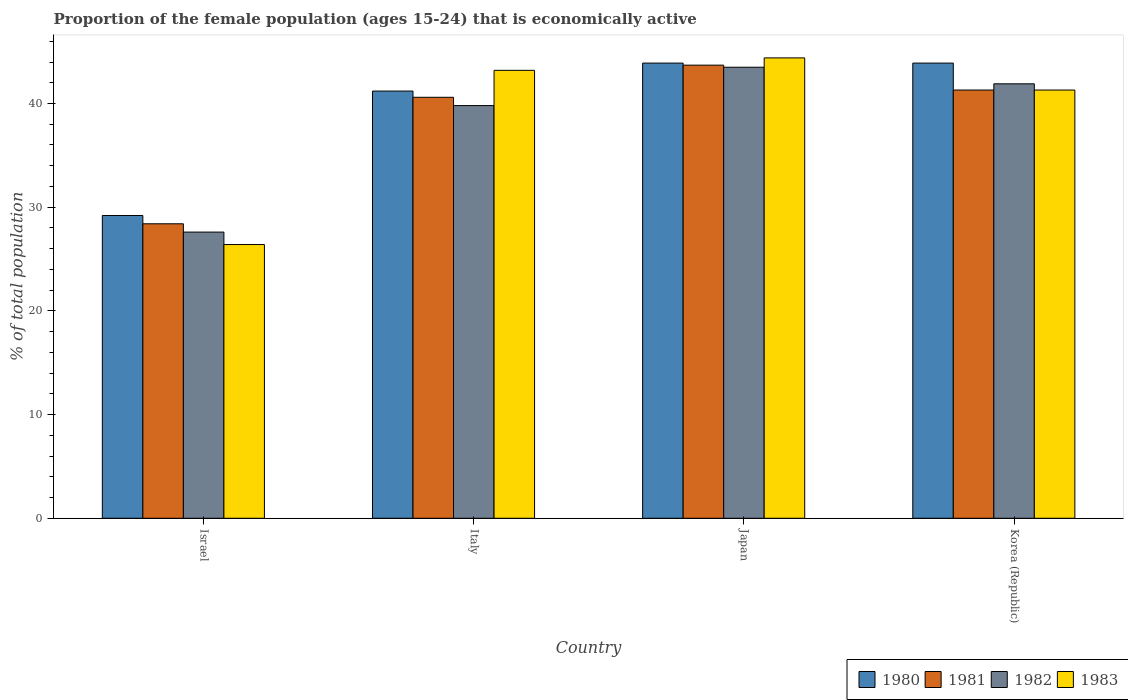How many groups of bars are there?
Offer a terse response. 4. Are the number of bars per tick equal to the number of legend labels?
Offer a very short reply. Yes. How many bars are there on the 4th tick from the left?
Offer a very short reply. 4. What is the label of the 2nd group of bars from the left?
Provide a short and direct response. Italy. What is the proportion of the female population that is economically active in 1981 in Italy?
Give a very brief answer. 40.6. Across all countries, what is the maximum proportion of the female population that is economically active in 1981?
Provide a short and direct response. 43.7. Across all countries, what is the minimum proportion of the female population that is economically active in 1982?
Ensure brevity in your answer.  27.6. In which country was the proportion of the female population that is economically active in 1980 maximum?
Offer a terse response. Japan. What is the total proportion of the female population that is economically active in 1982 in the graph?
Provide a succinct answer. 152.8. What is the difference between the proportion of the female population that is economically active in 1982 in Israel and that in Italy?
Offer a very short reply. -12.2. What is the difference between the proportion of the female population that is economically active in 1980 in Japan and the proportion of the female population that is economically active in 1983 in Italy?
Your response must be concise. 0.7. What is the average proportion of the female population that is economically active in 1982 per country?
Your answer should be very brief. 38.2. What is the difference between the proportion of the female population that is economically active of/in 1982 and proportion of the female population that is economically active of/in 1983 in Korea (Republic)?
Give a very brief answer. 0.6. In how many countries, is the proportion of the female population that is economically active in 1980 greater than 12 %?
Ensure brevity in your answer.  4. What is the ratio of the proportion of the female population that is economically active in 1980 in Italy to that in Korea (Republic)?
Ensure brevity in your answer.  0.94. Is the proportion of the female population that is economically active in 1982 in Italy less than that in Korea (Republic)?
Offer a very short reply. Yes. What is the difference between the highest and the second highest proportion of the female population that is economically active in 1981?
Make the answer very short. -0.7. What is the difference between the highest and the lowest proportion of the female population that is economically active in 1982?
Keep it short and to the point. 15.9. Is it the case that in every country, the sum of the proportion of the female population that is economically active in 1982 and proportion of the female population that is economically active in 1980 is greater than the sum of proportion of the female population that is economically active in 1981 and proportion of the female population that is economically active in 1983?
Offer a terse response. No. What does the 2nd bar from the left in Italy represents?
Ensure brevity in your answer.  1981. What does the 4th bar from the right in Italy represents?
Offer a very short reply. 1980. What is the difference between two consecutive major ticks on the Y-axis?
Your answer should be very brief. 10. Are the values on the major ticks of Y-axis written in scientific E-notation?
Provide a succinct answer. No. Does the graph contain any zero values?
Offer a very short reply. No. Does the graph contain grids?
Give a very brief answer. No. Where does the legend appear in the graph?
Ensure brevity in your answer.  Bottom right. How are the legend labels stacked?
Offer a very short reply. Horizontal. What is the title of the graph?
Ensure brevity in your answer.  Proportion of the female population (ages 15-24) that is economically active. Does "1988" appear as one of the legend labels in the graph?
Make the answer very short. No. What is the label or title of the X-axis?
Ensure brevity in your answer.  Country. What is the label or title of the Y-axis?
Provide a short and direct response. % of total population. What is the % of total population of 1980 in Israel?
Your response must be concise. 29.2. What is the % of total population of 1981 in Israel?
Make the answer very short. 28.4. What is the % of total population in 1982 in Israel?
Keep it short and to the point. 27.6. What is the % of total population in 1983 in Israel?
Offer a very short reply. 26.4. What is the % of total population of 1980 in Italy?
Keep it short and to the point. 41.2. What is the % of total population in 1981 in Italy?
Your answer should be compact. 40.6. What is the % of total population of 1982 in Italy?
Your response must be concise. 39.8. What is the % of total population in 1983 in Italy?
Make the answer very short. 43.2. What is the % of total population of 1980 in Japan?
Your answer should be compact. 43.9. What is the % of total population of 1981 in Japan?
Your response must be concise. 43.7. What is the % of total population in 1982 in Japan?
Give a very brief answer. 43.5. What is the % of total population of 1983 in Japan?
Make the answer very short. 44.4. What is the % of total population in 1980 in Korea (Republic)?
Make the answer very short. 43.9. What is the % of total population of 1981 in Korea (Republic)?
Your response must be concise. 41.3. What is the % of total population of 1982 in Korea (Republic)?
Your response must be concise. 41.9. What is the % of total population in 1983 in Korea (Republic)?
Make the answer very short. 41.3. Across all countries, what is the maximum % of total population in 1980?
Offer a terse response. 43.9. Across all countries, what is the maximum % of total population in 1981?
Your answer should be very brief. 43.7. Across all countries, what is the maximum % of total population in 1982?
Provide a short and direct response. 43.5. Across all countries, what is the maximum % of total population of 1983?
Provide a short and direct response. 44.4. Across all countries, what is the minimum % of total population of 1980?
Ensure brevity in your answer.  29.2. Across all countries, what is the minimum % of total population in 1981?
Keep it short and to the point. 28.4. Across all countries, what is the minimum % of total population of 1982?
Provide a short and direct response. 27.6. Across all countries, what is the minimum % of total population of 1983?
Provide a succinct answer. 26.4. What is the total % of total population in 1980 in the graph?
Provide a succinct answer. 158.2. What is the total % of total population of 1981 in the graph?
Offer a very short reply. 154. What is the total % of total population in 1982 in the graph?
Your answer should be very brief. 152.8. What is the total % of total population in 1983 in the graph?
Give a very brief answer. 155.3. What is the difference between the % of total population in 1983 in Israel and that in Italy?
Give a very brief answer. -16.8. What is the difference between the % of total population in 1980 in Israel and that in Japan?
Give a very brief answer. -14.7. What is the difference between the % of total population of 1981 in Israel and that in Japan?
Provide a succinct answer. -15.3. What is the difference between the % of total population of 1982 in Israel and that in Japan?
Make the answer very short. -15.9. What is the difference between the % of total population in 1980 in Israel and that in Korea (Republic)?
Keep it short and to the point. -14.7. What is the difference between the % of total population in 1982 in Israel and that in Korea (Republic)?
Give a very brief answer. -14.3. What is the difference between the % of total population of 1983 in Israel and that in Korea (Republic)?
Your answer should be compact. -14.9. What is the difference between the % of total population in 1981 in Italy and that in Japan?
Offer a terse response. -3.1. What is the difference between the % of total population in 1982 in Italy and that in Japan?
Your response must be concise. -3.7. What is the difference between the % of total population of 1980 in Italy and that in Korea (Republic)?
Provide a succinct answer. -2.7. What is the difference between the % of total population of 1981 in Italy and that in Korea (Republic)?
Your response must be concise. -0.7. What is the difference between the % of total population of 1982 in Italy and that in Korea (Republic)?
Make the answer very short. -2.1. What is the difference between the % of total population of 1983 in Italy and that in Korea (Republic)?
Provide a short and direct response. 1.9. What is the difference between the % of total population in 1982 in Japan and that in Korea (Republic)?
Give a very brief answer. 1.6. What is the difference between the % of total population of 1980 in Israel and the % of total population of 1982 in Italy?
Offer a very short reply. -10.6. What is the difference between the % of total population of 1980 in Israel and the % of total population of 1983 in Italy?
Offer a very short reply. -14. What is the difference between the % of total population in 1981 in Israel and the % of total population in 1982 in Italy?
Make the answer very short. -11.4. What is the difference between the % of total population of 1981 in Israel and the % of total population of 1983 in Italy?
Provide a short and direct response. -14.8. What is the difference between the % of total population in 1982 in Israel and the % of total population in 1983 in Italy?
Your answer should be very brief. -15.6. What is the difference between the % of total population in 1980 in Israel and the % of total population in 1982 in Japan?
Ensure brevity in your answer.  -14.3. What is the difference between the % of total population of 1980 in Israel and the % of total population of 1983 in Japan?
Provide a succinct answer. -15.2. What is the difference between the % of total population of 1981 in Israel and the % of total population of 1982 in Japan?
Offer a terse response. -15.1. What is the difference between the % of total population in 1982 in Israel and the % of total population in 1983 in Japan?
Ensure brevity in your answer.  -16.8. What is the difference between the % of total population of 1980 in Israel and the % of total population of 1981 in Korea (Republic)?
Provide a succinct answer. -12.1. What is the difference between the % of total population in 1980 in Israel and the % of total population in 1982 in Korea (Republic)?
Your response must be concise. -12.7. What is the difference between the % of total population in 1981 in Israel and the % of total population in 1983 in Korea (Republic)?
Your answer should be compact. -12.9. What is the difference between the % of total population in 1982 in Israel and the % of total population in 1983 in Korea (Republic)?
Provide a short and direct response. -13.7. What is the difference between the % of total population in 1980 in Italy and the % of total population in 1981 in Japan?
Ensure brevity in your answer.  -2.5. What is the difference between the % of total population of 1980 in Italy and the % of total population of 1983 in Japan?
Your response must be concise. -3.2. What is the difference between the % of total population of 1981 in Italy and the % of total population of 1983 in Japan?
Provide a succinct answer. -3.8. What is the difference between the % of total population in 1982 in Italy and the % of total population in 1983 in Japan?
Give a very brief answer. -4.6. What is the difference between the % of total population of 1980 in Italy and the % of total population of 1981 in Korea (Republic)?
Your answer should be compact. -0.1. What is the difference between the % of total population in 1980 in Italy and the % of total population in 1982 in Korea (Republic)?
Offer a very short reply. -0.7. What is the difference between the % of total population in 1980 in Italy and the % of total population in 1983 in Korea (Republic)?
Keep it short and to the point. -0.1. What is the difference between the % of total population of 1981 in Italy and the % of total population of 1982 in Korea (Republic)?
Keep it short and to the point. -1.3. What is the difference between the % of total population of 1981 in Italy and the % of total population of 1983 in Korea (Republic)?
Keep it short and to the point. -0.7. What is the difference between the % of total population in 1980 in Japan and the % of total population in 1982 in Korea (Republic)?
Ensure brevity in your answer.  2. What is the difference between the % of total population in 1981 in Japan and the % of total population in 1982 in Korea (Republic)?
Keep it short and to the point. 1.8. What is the average % of total population of 1980 per country?
Provide a succinct answer. 39.55. What is the average % of total population in 1981 per country?
Ensure brevity in your answer.  38.5. What is the average % of total population of 1982 per country?
Offer a terse response. 38.2. What is the average % of total population of 1983 per country?
Give a very brief answer. 38.83. What is the difference between the % of total population in 1980 and % of total population in 1981 in Israel?
Your answer should be compact. 0.8. What is the difference between the % of total population of 1980 and % of total population of 1982 in Israel?
Give a very brief answer. 1.6. What is the difference between the % of total population in 1980 and % of total population in 1983 in Israel?
Provide a short and direct response. 2.8. What is the difference between the % of total population in 1981 and % of total population in 1982 in Israel?
Your answer should be very brief. 0.8. What is the difference between the % of total population of 1982 and % of total population of 1983 in Israel?
Provide a succinct answer. 1.2. What is the difference between the % of total population of 1981 and % of total population of 1983 in Italy?
Provide a short and direct response. -2.6. What is the difference between the % of total population of 1982 and % of total population of 1983 in Italy?
Provide a short and direct response. -3.4. What is the difference between the % of total population of 1980 and % of total population of 1983 in Japan?
Provide a succinct answer. -0.5. What is the difference between the % of total population in 1981 and % of total population in 1982 in Japan?
Keep it short and to the point. 0.2. What is the difference between the % of total population of 1981 and % of total population of 1983 in Japan?
Your answer should be compact. -0.7. What is the difference between the % of total population of 1982 and % of total population of 1983 in Japan?
Offer a terse response. -0.9. What is the difference between the % of total population of 1980 and % of total population of 1982 in Korea (Republic)?
Ensure brevity in your answer.  2. What is the difference between the % of total population in 1980 and % of total population in 1983 in Korea (Republic)?
Keep it short and to the point. 2.6. What is the difference between the % of total population in 1981 and % of total population in 1982 in Korea (Republic)?
Offer a terse response. -0.6. What is the difference between the % of total population of 1981 and % of total population of 1983 in Korea (Republic)?
Provide a short and direct response. 0. What is the difference between the % of total population in 1982 and % of total population in 1983 in Korea (Republic)?
Keep it short and to the point. 0.6. What is the ratio of the % of total population of 1980 in Israel to that in Italy?
Offer a terse response. 0.71. What is the ratio of the % of total population in 1981 in Israel to that in Italy?
Provide a short and direct response. 0.7. What is the ratio of the % of total population of 1982 in Israel to that in Italy?
Offer a terse response. 0.69. What is the ratio of the % of total population of 1983 in Israel to that in Italy?
Provide a short and direct response. 0.61. What is the ratio of the % of total population in 1980 in Israel to that in Japan?
Offer a terse response. 0.67. What is the ratio of the % of total population in 1981 in Israel to that in Japan?
Provide a succinct answer. 0.65. What is the ratio of the % of total population in 1982 in Israel to that in Japan?
Ensure brevity in your answer.  0.63. What is the ratio of the % of total population of 1983 in Israel to that in Japan?
Make the answer very short. 0.59. What is the ratio of the % of total population in 1980 in Israel to that in Korea (Republic)?
Offer a terse response. 0.67. What is the ratio of the % of total population of 1981 in Israel to that in Korea (Republic)?
Your answer should be compact. 0.69. What is the ratio of the % of total population in 1982 in Israel to that in Korea (Republic)?
Give a very brief answer. 0.66. What is the ratio of the % of total population in 1983 in Israel to that in Korea (Republic)?
Ensure brevity in your answer.  0.64. What is the ratio of the % of total population in 1980 in Italy to that in Japan?
Your answer should be very brief. 0.94. What is the ratio of the % of total population of 1981 in Italy to that in Japan?
Make the answer very short. 0.93. What is the ratio of the % of total population in 1982 in Italy to that in Japan?
Offer a terse response. 0.91. What is the ratio of the % of total population in 1983 in Italy to that in Japan?
Give a very brief answer. 0.97. What is the ratio of the % of total population in 1980 in Italy to that in Korea (Republic)?
Provide a short and direct response. 0.94. What is the ratio of the % of total population of 1981 in Italy to that in Korea (Republic)?
Offer a very short reply. 0.98. What is the ratio of the % of total population of 1982 in Italy to that in Korea (Republic)?
Provide a short and direct response. 0.95. What is the ratio of the % of total population of 1983 in Italy to that in Korea (Republic)?
Make the answer very short. 1.05. What is the ratio of the % of total population of 1980 in Japan to that in Korea (Republic)?
Your response must be concise. 1. What is the ratio of the % of total population of 1981 in Japan to that in Korea (Republic)?
Your response must be concise. 1.06. What is the ratio of the % of total population in 1982 in Japan to that in Korea (Republic)?
Your response must be concise. 1.04. What is the ratio of the % of total population in 1983 in Japan to that in Korea (Republic)?
Ensure brevity in your answer.  1.08. What is the difference between the highest and the second highest % of total population of 1981?
Make the answer very short. 2.4. What is the difference between the highest and the second highest % of total population of 1982?
Offer a very short reply. 1.6. What is the difference between the highest and the lowest % of total population in 1982?
Make the answer very short. 15.9. 